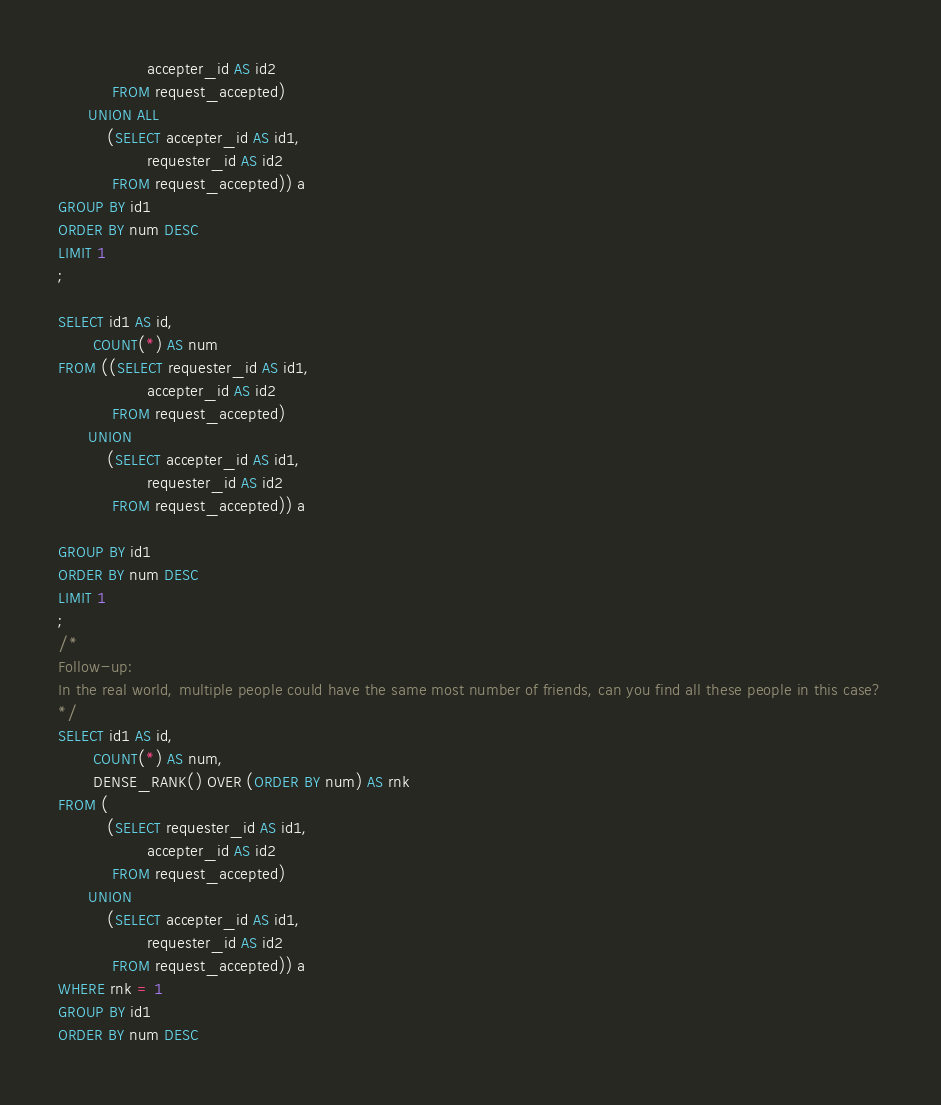Convert code to text. <code><loc_0><loc_0><loc_500><loc_500><_SQL_>                  accepter_id AS id2
           FROM request_accepted)
      UNION ALL
          (SELECT accepter_id AS id1,
                  requester_id AS id2
           FROM request_accepted)) a
GROUP BY id1
ORDER BY num DESC
LIMIT 1
;

SELECT id1 AS id,
       COUNT(*) AS num
FROM ((SELECT requester_id AS id1,
                  accepter_id AS id2
           FROM request_accepted)
      UNION 
          (SELECT accepter_id AS id1,
                  requester_id AS id2
           FROM request_accepted)) a
           
GROUP BY id1
ORDER BY num DESC
LIMIT 1
;
/*
Follow-up:
In the real world, multiple people could have the same most number of friends, can you find all these people in this case?
*/
SELECT id1 AS id,
       COUNT(*) AS num,
       DENSE_RANK() OVER (ORDER BY num) AS rnk
FROM (
          (SELECT requester_id AS id1,
                  accepter_id AS id2
           FROM request_accepted)
      UNION
          (SELECT accepter_id AS id1,
                  requester_id AS id2
           FROM request_accepted)) a
WHERE rnk = 1
GROUP BY id1
ORDER BY num DESC

</code> 